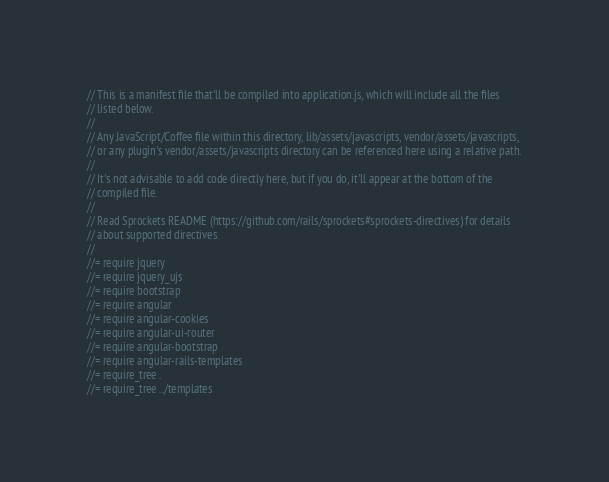Convert code to text. <code><loc_0><loc_0><loc_500><loc_500><_JavaScript_>// This is a manifest file that'll be compiled into application.js, which will include all the files
// listed below.
//
// Any JavaScript/Coffee file within this directory, lib/assets/javascripts, vendor/assets/javascripts,
// or any plugin's vendor/assets/javascripts directory can be referenced here using a relative path.
//
// It's not advisable to add code directly here, but if you do, it'll appear at the bottom of the
// compiled file.
//
// Read Sprockets README (https://github.com/rails/sprockets#sprockets-directives) for details
// about supported directives.
//
//= require jquery
//= require jquery_ujs
//= require bootstrap
//= require angular
//= require angular-cookies
//= require angular-ui-router
//= require angular-bootstrap
//= require angular-rails-templates
//= require_tree .
//= require_tree ../templates
</code> 